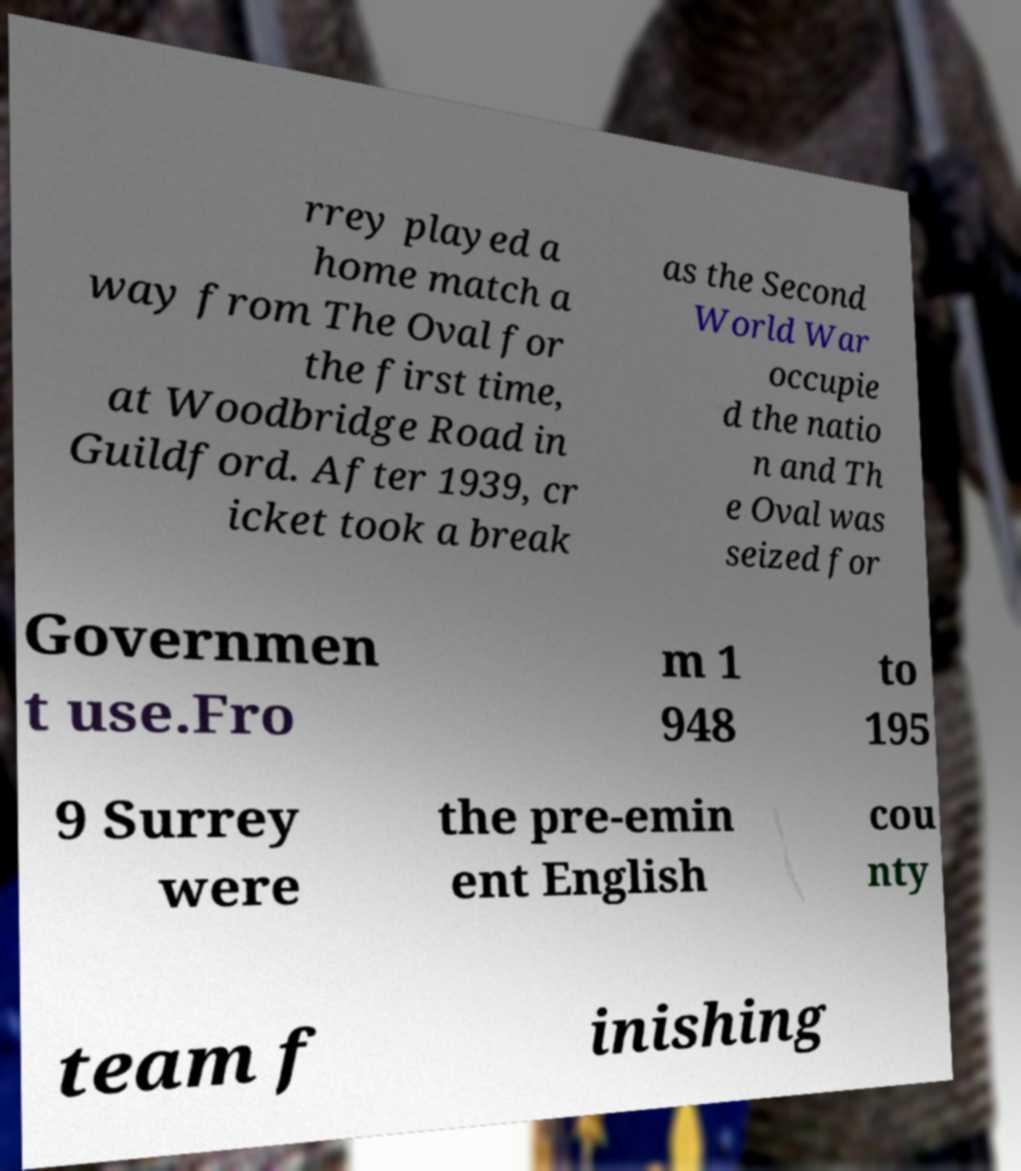Could you extract and type out the text from this image? rrey played a home match a way from The Oval for the first time, at Woodbridge Road in Guildford. After 1939, cr icket took a break as the Second World War occupie d the natio n and Th e Oval was seized for Governmen t use.Fro m 1 948 to 195 9 Surrey were the pre-emin ent English cou nty team f inishing 